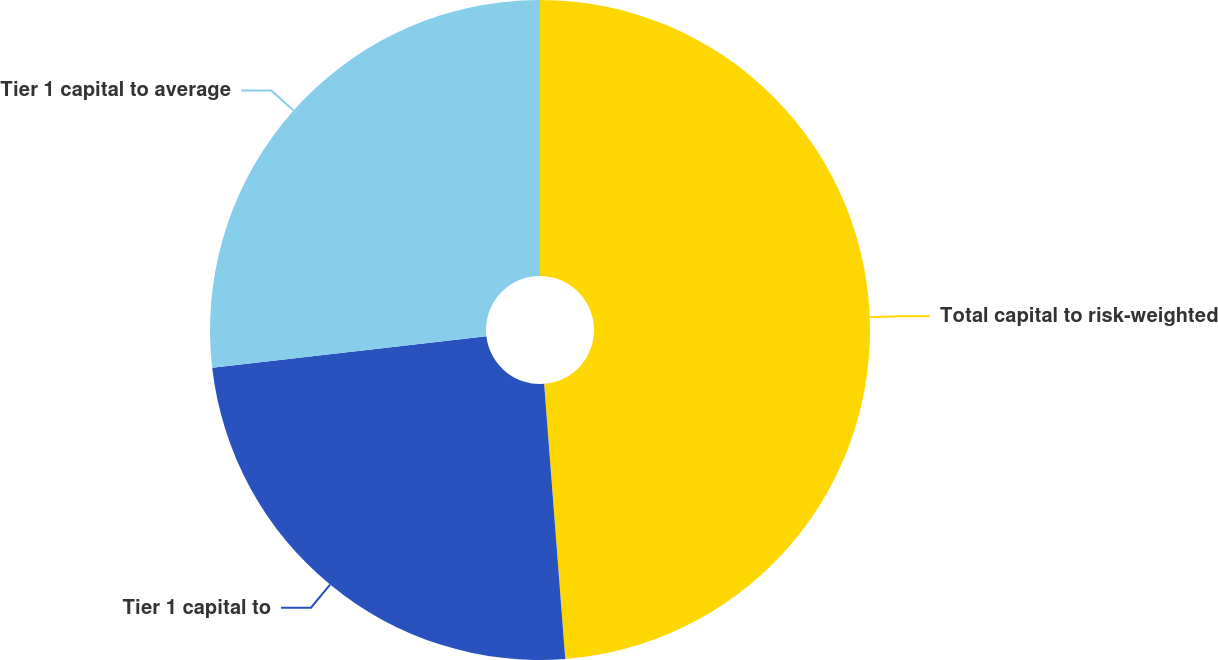<chart> <loc_0><loc_0><loc_500><loc_500><pie_chart><fcel>Total capital to risk-weighted<fcel>Tier 1 capital to<fcel>Tier 1 capital to average<nl><fcel>48.78%<fcel>24.39%<fcel>26.83%<nl></chart> 